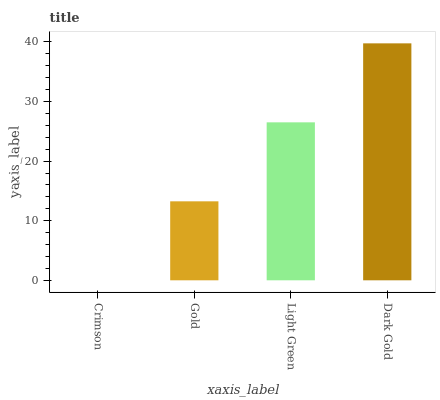Is Crimson the minimum?
Answer yes or no. Yes. Is Dark Gold the maximum?
Answer yes or no. Yes. Is Gold the minimum?
Answer yes or no. No. Is Gold the maximum?
Answer yes or no. No. Is Gold greater than Crimson?
Answer yes or no. Yes. Is Crimson less than Gold?
Answer yes or no. Yes. Is Crimson greater than Gold?
Answer yes or no. No. Is Gold less than Crimson?
Answer yes or no. No. Is Light Green the high median?
Answer yes or no. Yes. Is Gold the low median?
Answer yes or no. Yes. Is Crimson the high median?
Answer yes or no. No. Is Dark Gold the low median?
Answer yes or no. No. 